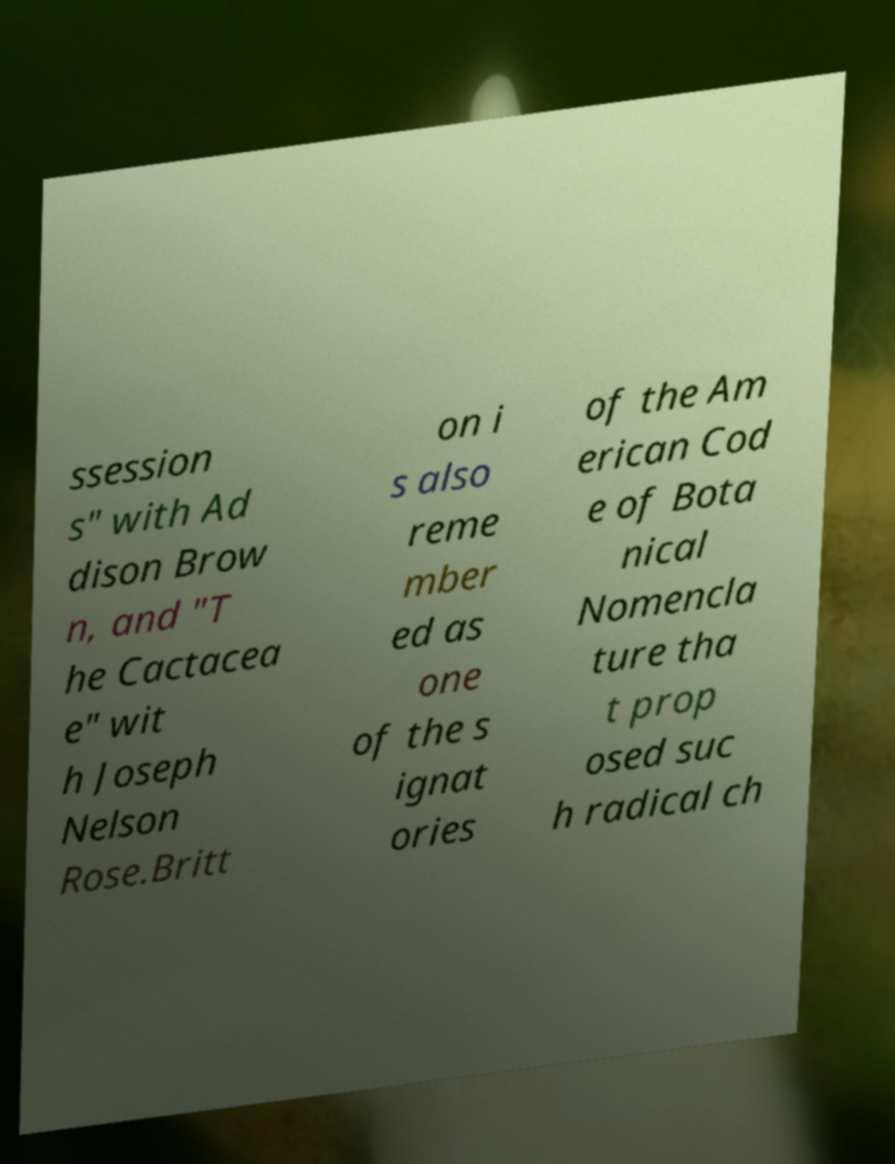Please identify and transcribe the text found in this image. ssession s" with Ad dison Brow n, and "T he Cactacea e" wit h Joseph Nelson Rose.Britt on i s also reme mber ed as one of the s ignat ories of the Am erican Cod e of Bota nical Nomencla ture tha t prop osed suc h radical ch 